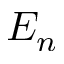Convert formula to latex. <formula><loc_0><loc_0><loc_500><loc_500>E _ { n }</formula> 